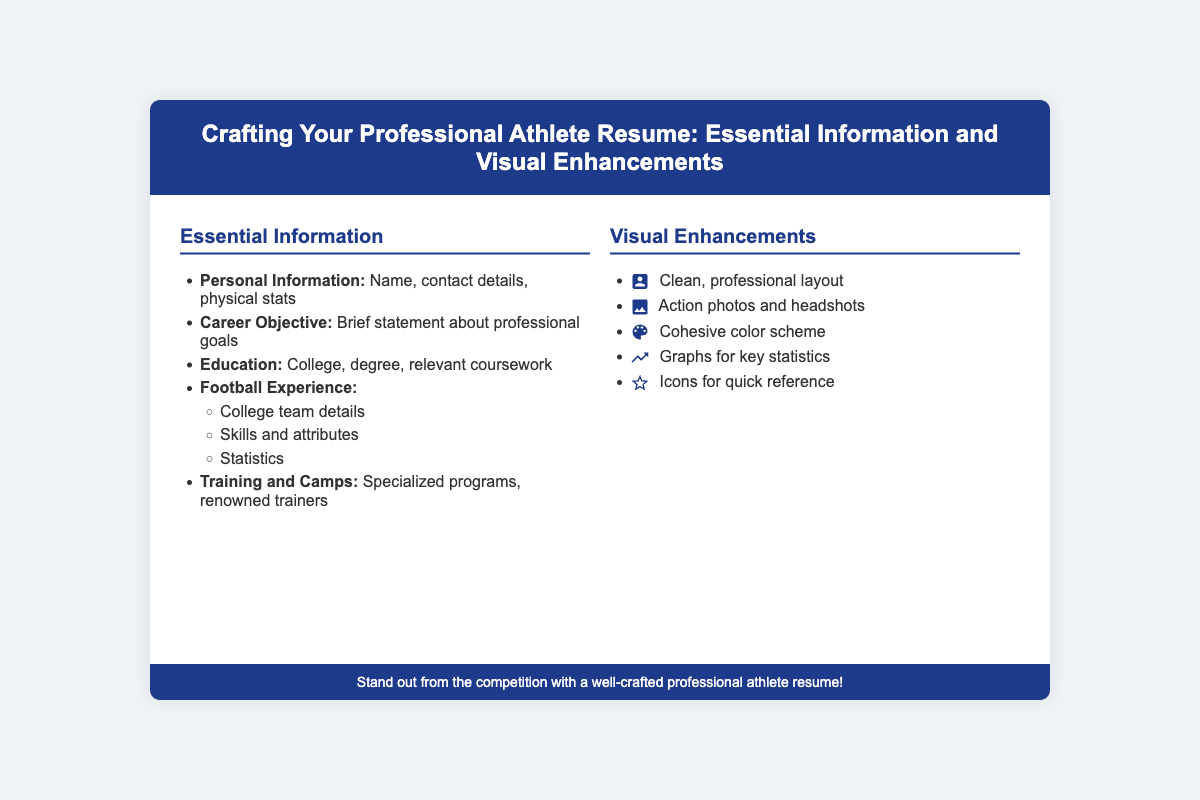what is the title of the presentation? The title of the presentation is prominently displayed in the header section of the slide.
Answer: Crafting Your Professional Athlete Resume: Essential Information and Visual Enhancements how many main sections are there in the content? The content is divided into two main sections, that is Essential Information and Visual Enhancements.
Answer: 2 what information is included under Personal Information? The document specifies what details are included in the Personal Information section.
Answer: Name, contact details, physical stats which section discusses action photos? The section that includes action photos is dedicated to visual enhancements for the resume.
Answer: Visual Enhancements what is one visual enhancement feature mentioned? The document lists several visual enhancements that can be included in a resume.
Answer: Clean, professional layout how many specific types of visual enhancements are listed? The document provides a clear count of the various visual enhancements that can be implemented.
Answer: 5 what should be included in the Career Objective? The document states that the Career Objective should reflect the individual's professional aspirations.
Answer: Brief statement about professional goals what kind of statistics are mentioned for Football Experience? The specific type of statistics mentioned relates to the player's performance metrics.
Answer: Statistics 